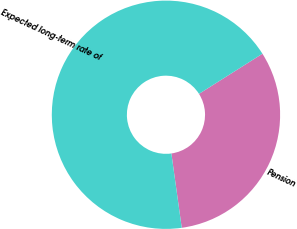Convert chart. <chart><loc_0><loc_0><loc_500><loc_500><pie_chart><fcel>Pension<fcel>Expected long-term rate of<nl><fcel>31.77%<fcel>68.23%<nl></chart> 